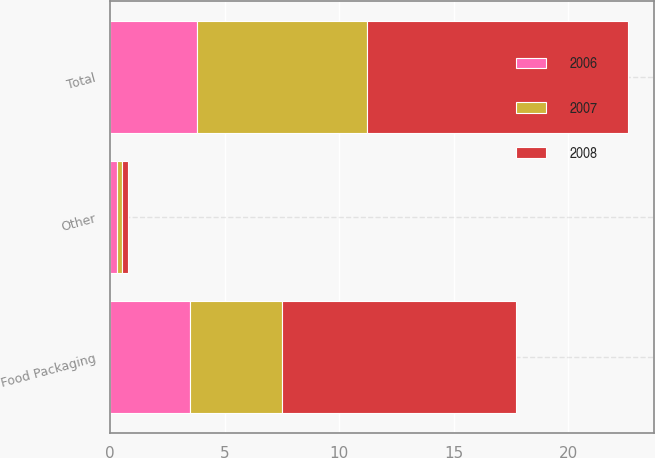Convert chart to OTSL. <chart><loc_0><loc_0><loc_500><loc_500><stacked_bar_chart><ecel><fcel>Food Packaging<fcel>Other<fcel>Total<nl><fcel>2007<fcel>4<fcel>0.2<fcel>7.4<nl><fcel>2008<fcel>10.2<fcel>0.3<fcel>11.4<nl><fcel>2006<fcel>3.5<fcel>0.3<fcel>3.8<nl></chart> 